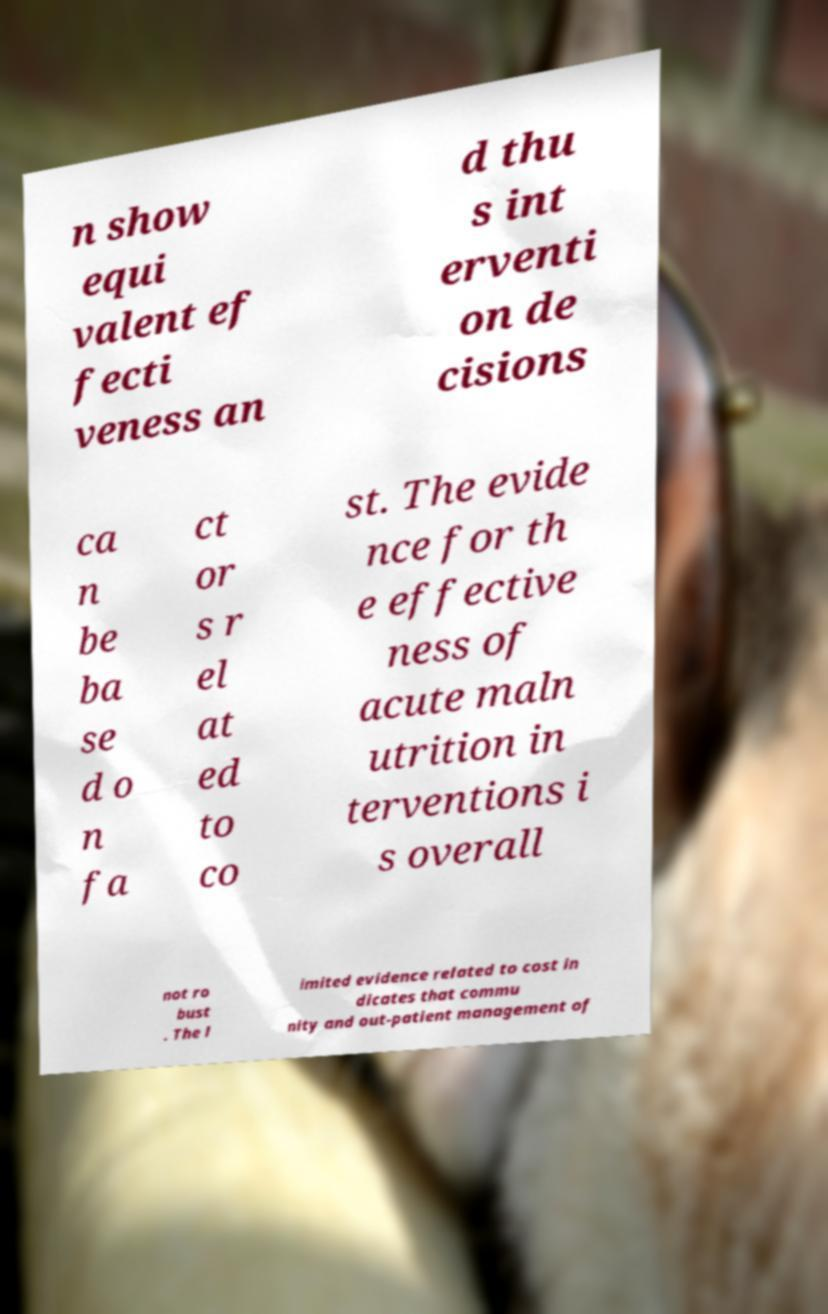Can you read and provide the text displayed in the image?This photo seems to have some interesting text. Can you extract and type it out for me? n show equi valent ef fecti veness an d thu s int erventi on de cisions ca n be ba se d o n fa ct or s r el at ed to co st. The evide nce for th e effective ness of acute maln utrition in terventions i s overall not ro bust . The l imited evidence related to cost in dicates that commu nity and out-patient management of 